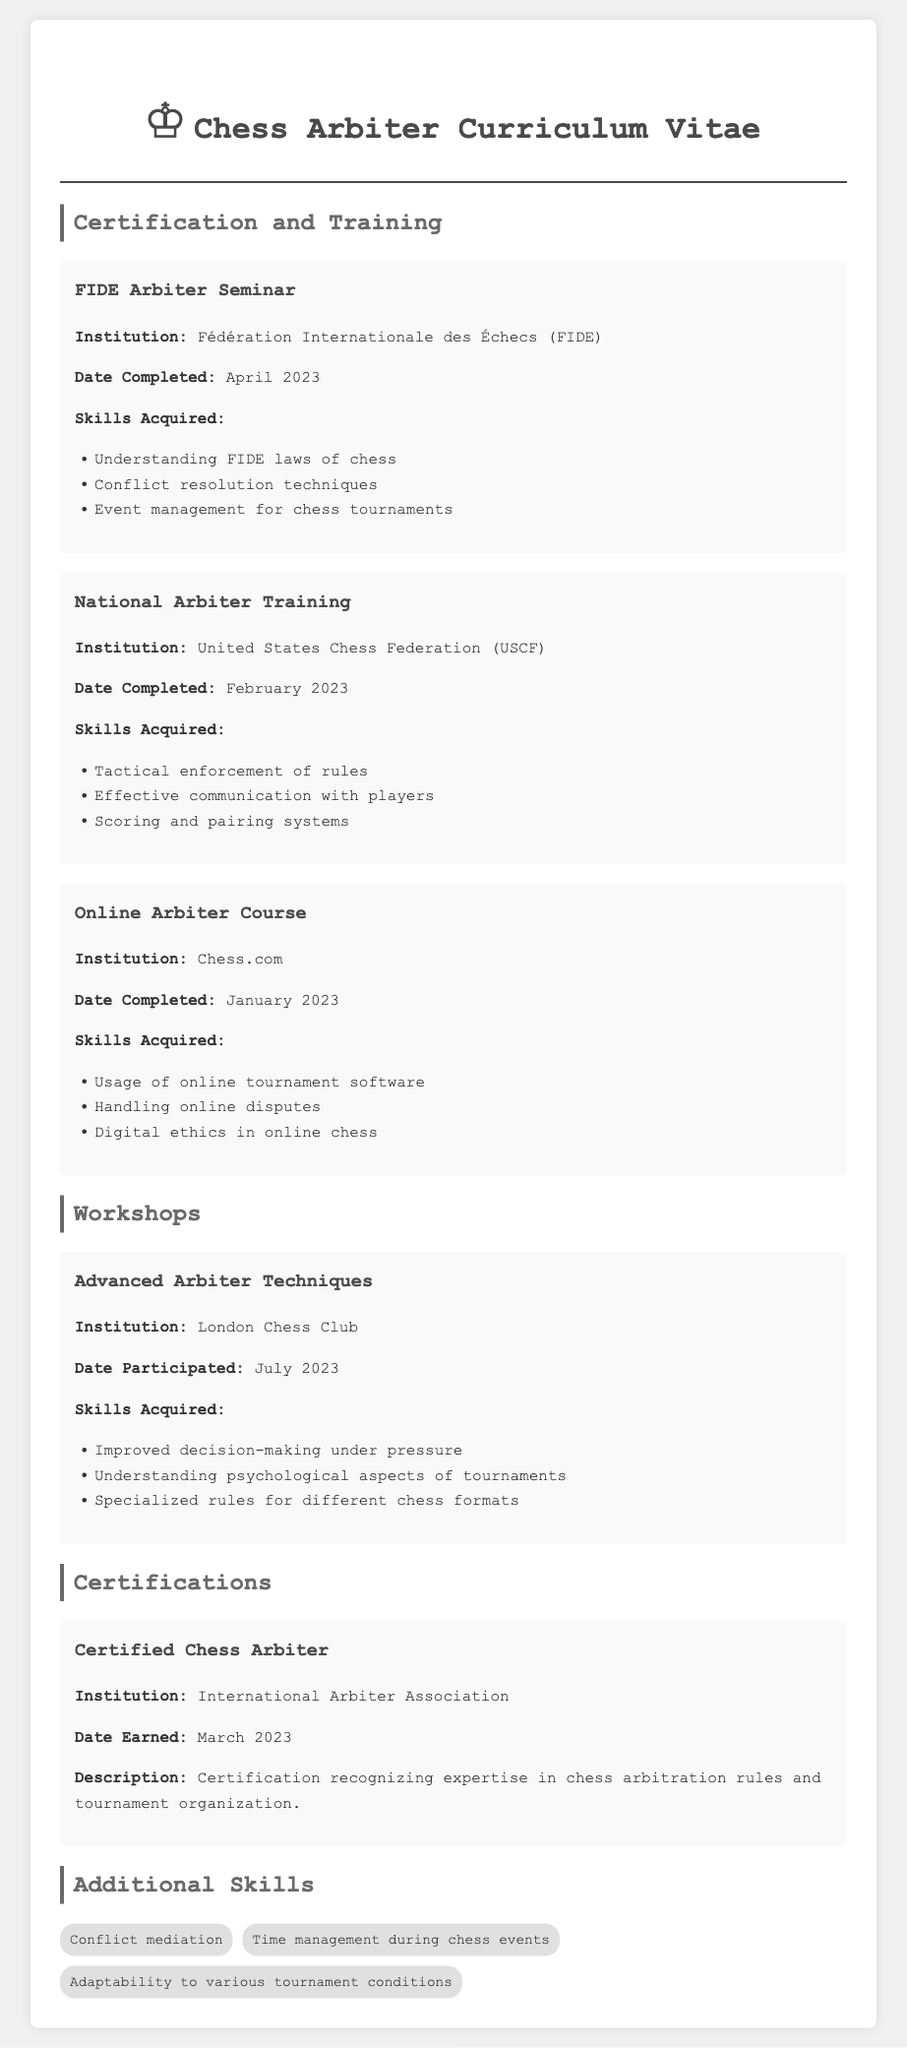what is the institution for the FIDE Arbiter Seminar? The FIDE Arbiter Seminar is conducted by the Fédération Internationale des Échecs (FIDE).
Answer: Fédération Internationale des Échecs (FIDE) when was the National Arbiter Training completed? The National Arbiter Training was completed in February 2023.
Answer: February 2023 what skill is acquired from the Online Arbiter Course? The Online Arbiter Course provides skills in handling online disputes.
Answer: Handling online disputes which workshop focuses on advanced techniques? The workshop that focuses on advanced techniques is the Advanced Arbiter Techniques.
Answer: Advanced Arbiter Techniques what certification was earned in March 2023? The certification earned in March 2023 is the Certified Chess Arbiter.
Answer: Certified Chess Arbiter which skill relates to managing different conditions during tournaments? The skill that relates to managing different conditions is adaptability to various tournament conditions.
Answer: Adaptability to various tournament conditions how many courses are listed under Certification and Training? There are three courses listed under Certification and Training.
Answer: Three what organization issued the Certified Chess Arbiter? The Certified Chess Arbiter was issued by the International Arbiter Association.
Answer: International Arbiter Association what date was the Advanced Arbiter Techniques workshop held? The Advanced Arbiter Techniques workshop was held in July 2023.
Answer: July 2023 